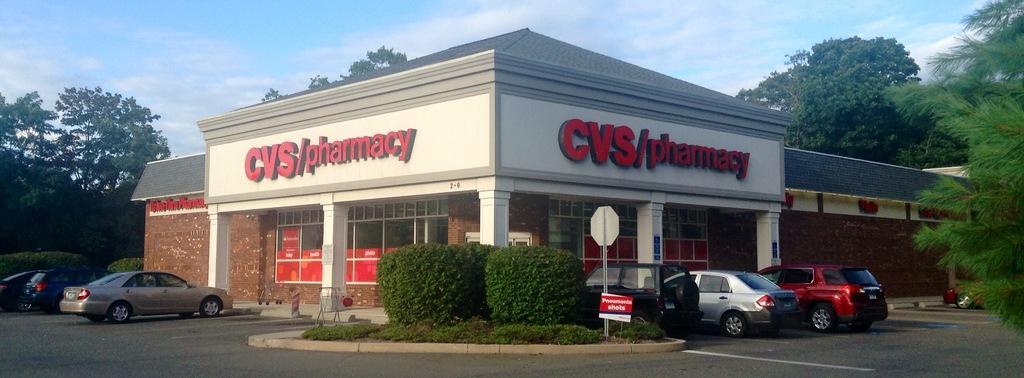Describe this image in one or two sentences. In the foreground of this picture, there is a pharmacy as the text written on it as "CVS/PHARMACY". In front to it there are cars, plants and sign board. In the background, there are trees, sky and the cloud. 